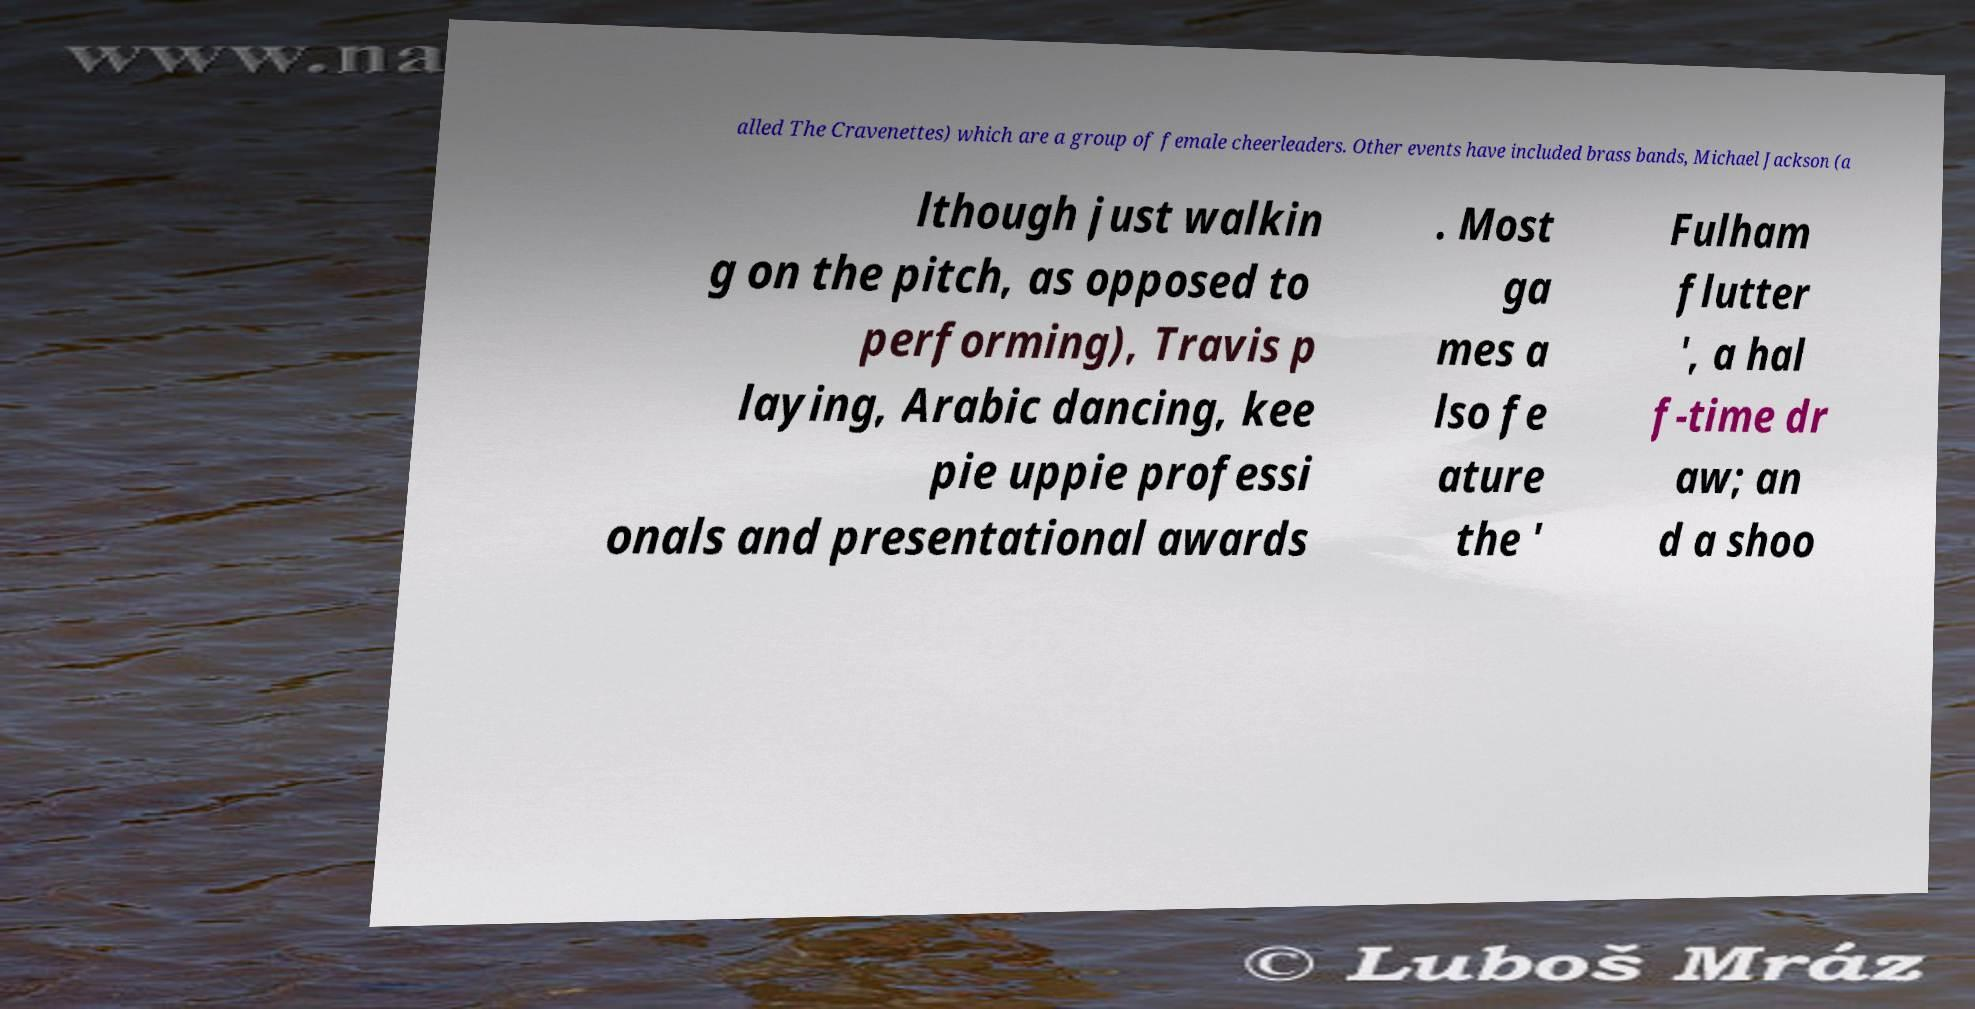Can you read and provide the text displayed in the image?This photo seems to have some interesting text. Can you extract and type it out for me? alled The Cravenettes) which are a group of female cheerleaders. Other events have included brass bands, Michael Jackson (a lthough just walkin g on the pitch, as opposed to performing), Travis p laying, Arabic dancing, kee pie uppie professi onals and presentational awards . Most ga mes a lso fe ature the ' Fulham flutter ', a hal f-time dr aw; an d a shoo 